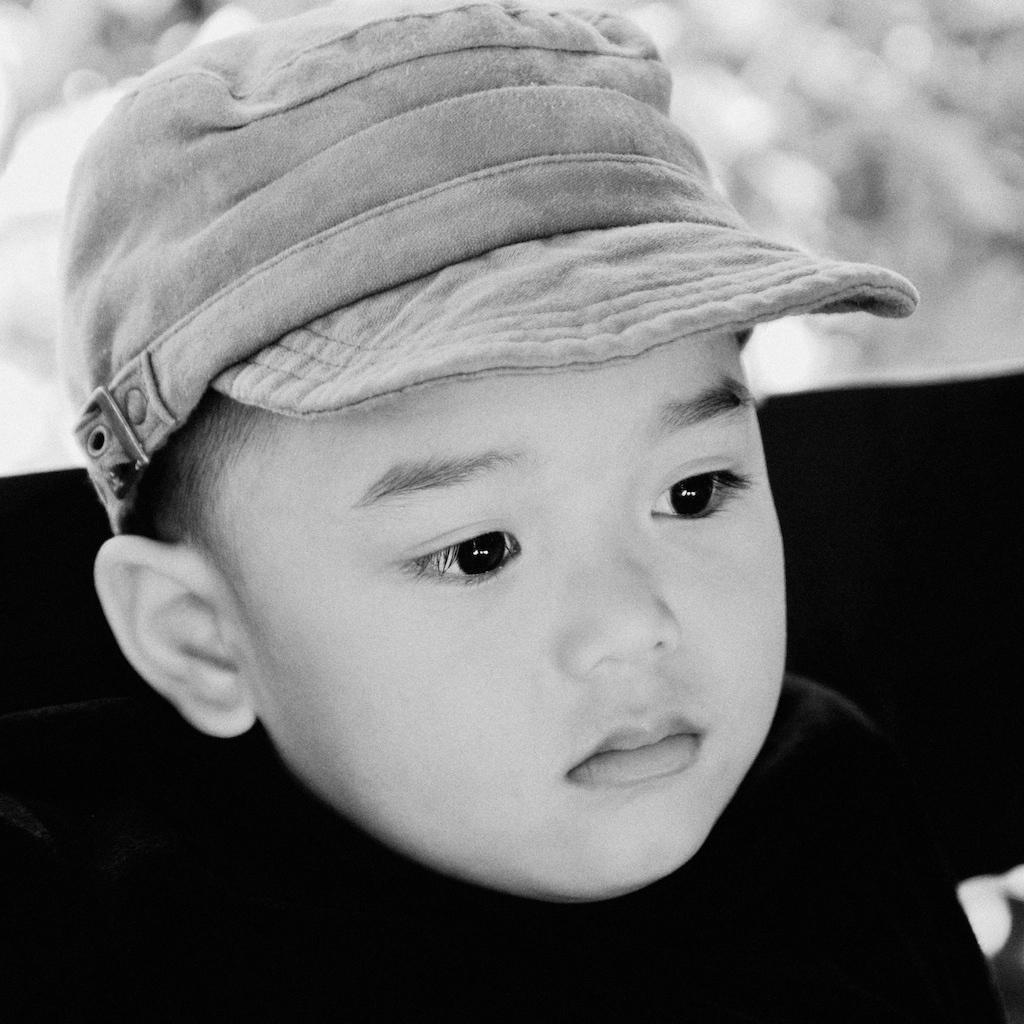How would you summarize this image in a sentence or two? In this image I can see the baby is wearing the cap and the image is in black and white. 